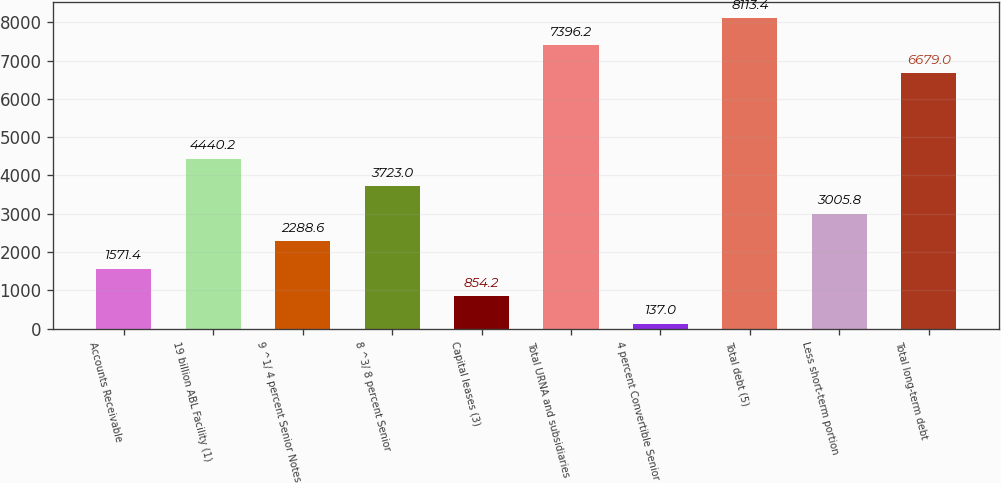<chart> <loc_0><loc_0><loc_500><loc_500><bar_chart><fcel>Accounts Receivable<fcel>19 billion ABL Facility (1)<fcel>9 ^1/ 4 percent Senior Notes<fcel>8 ^3/ 8 percent Senior<fcel>Capital leases (3)<fcel>Total URNA and subsidiaries<fcel>4 percent Convertible Senior<fcel>Total debt (5)<fcel>Less short-term portion<fcel>Total long-term debt<nl><fcel>1571.4<fcel>4440.2<fcel>2288.6<fcel>3723<fcel>854.2<fcel>7396.2<fcel>137<fcel>8113.4<fcel>3005.8<fcel>6679<nl></chart> 